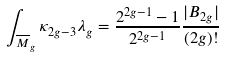Convert formula to latex. <formula><loc_0><loc_0><loc_500><loc_500>\int _ { \overline { M } _ { g } } \kappa _ { 2 g - 3 } \lambda _ { g } = \frac { 2 ^ { 2 g - 1 } - 1 } { 2 ^ { 2 g - 1 } } \frac { | B _ { 2 g } | } { ( 2 g ) ! }</formula> 